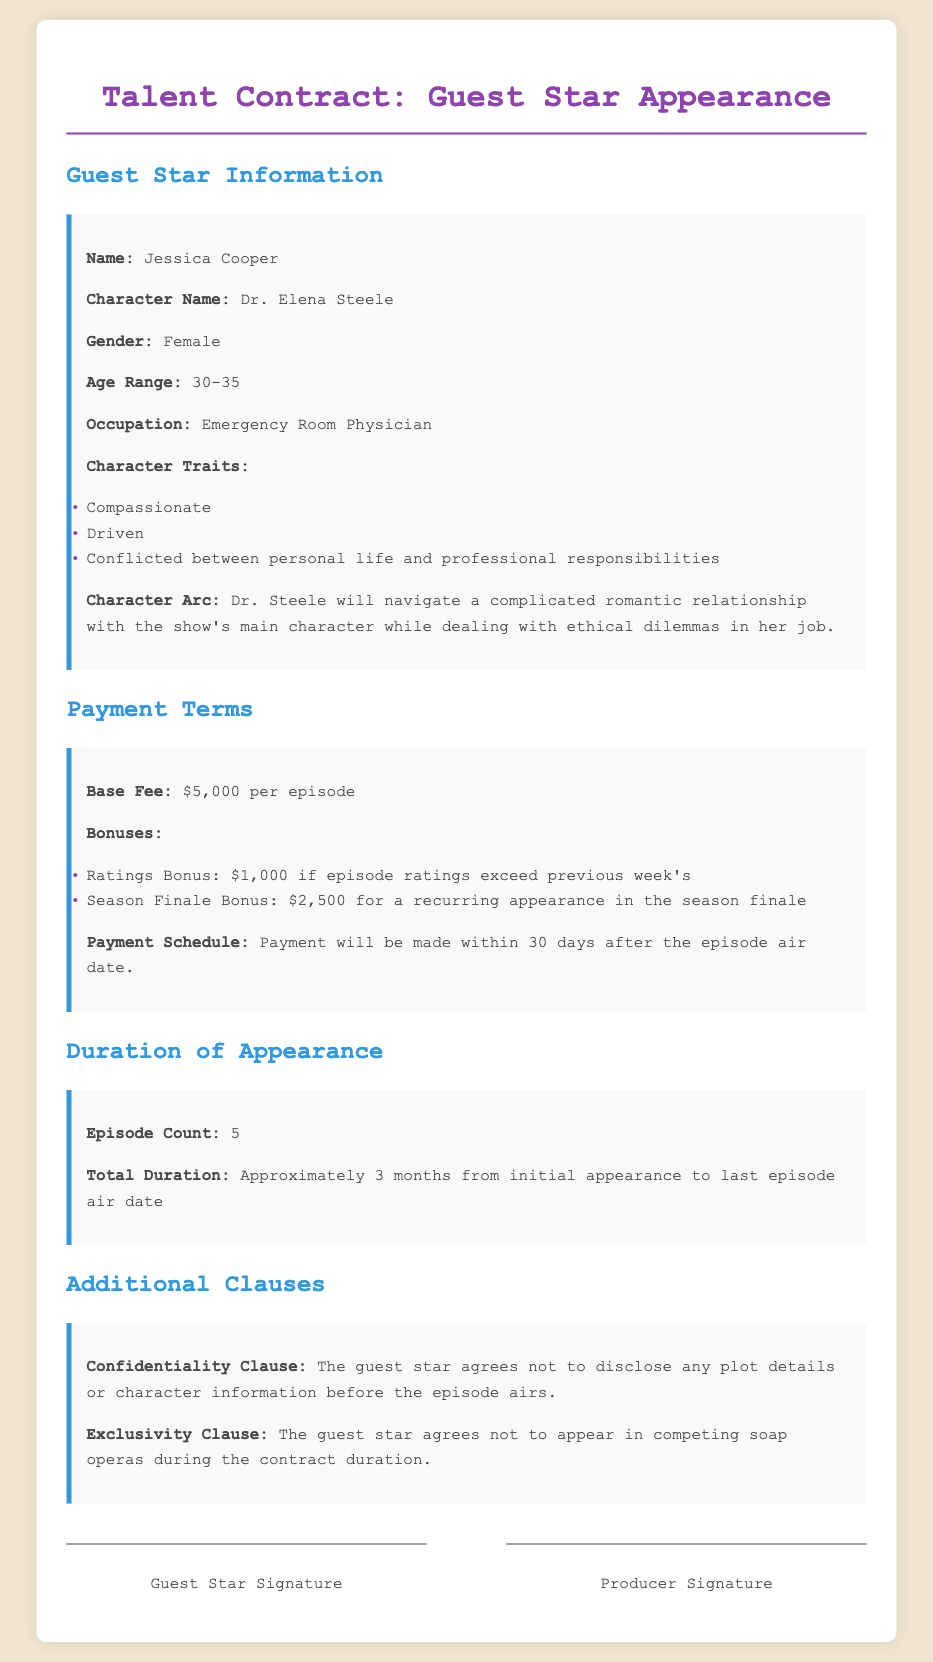what is the base fee per episode? The base fee per episode is specified in the payment terms section of the document.
Answer: $5,000 who is the guest star? The guest star's name is mentioned in the guest star information section of the document.
Answer: Jessica Cooper how many episodes will the guest star appear in? The number of episodes is provided in the duration of appearance section.
Answer: 5 what is the character name of the guest star? The character name is listed in the guest star information section of the document.
Answer: Dr. Elena Steele what bonus is granted if episode ratings exceed the previous week's? The specific bonus is described in the payment terms section of the document.
Answer: $1,000 what is the total duration of the guest star's appearance? The total duration is mentioned in the duration of appearance section of the document.
Answer: Approximately 3 months what is the confidentiality clause about? The confidentiality clause is outlined in the additional clauses section.
Answer: Not to disclose any plot details or character information before the episode airs what is the age range for the character? The age range is specified in the character information section of the document.
Answer: 30-35 what is the exclusivity clause? The exclusivity clause details are specified in the additional clauses section of the document.
Answer: Not to appear in competing soap operas during the contract duration 